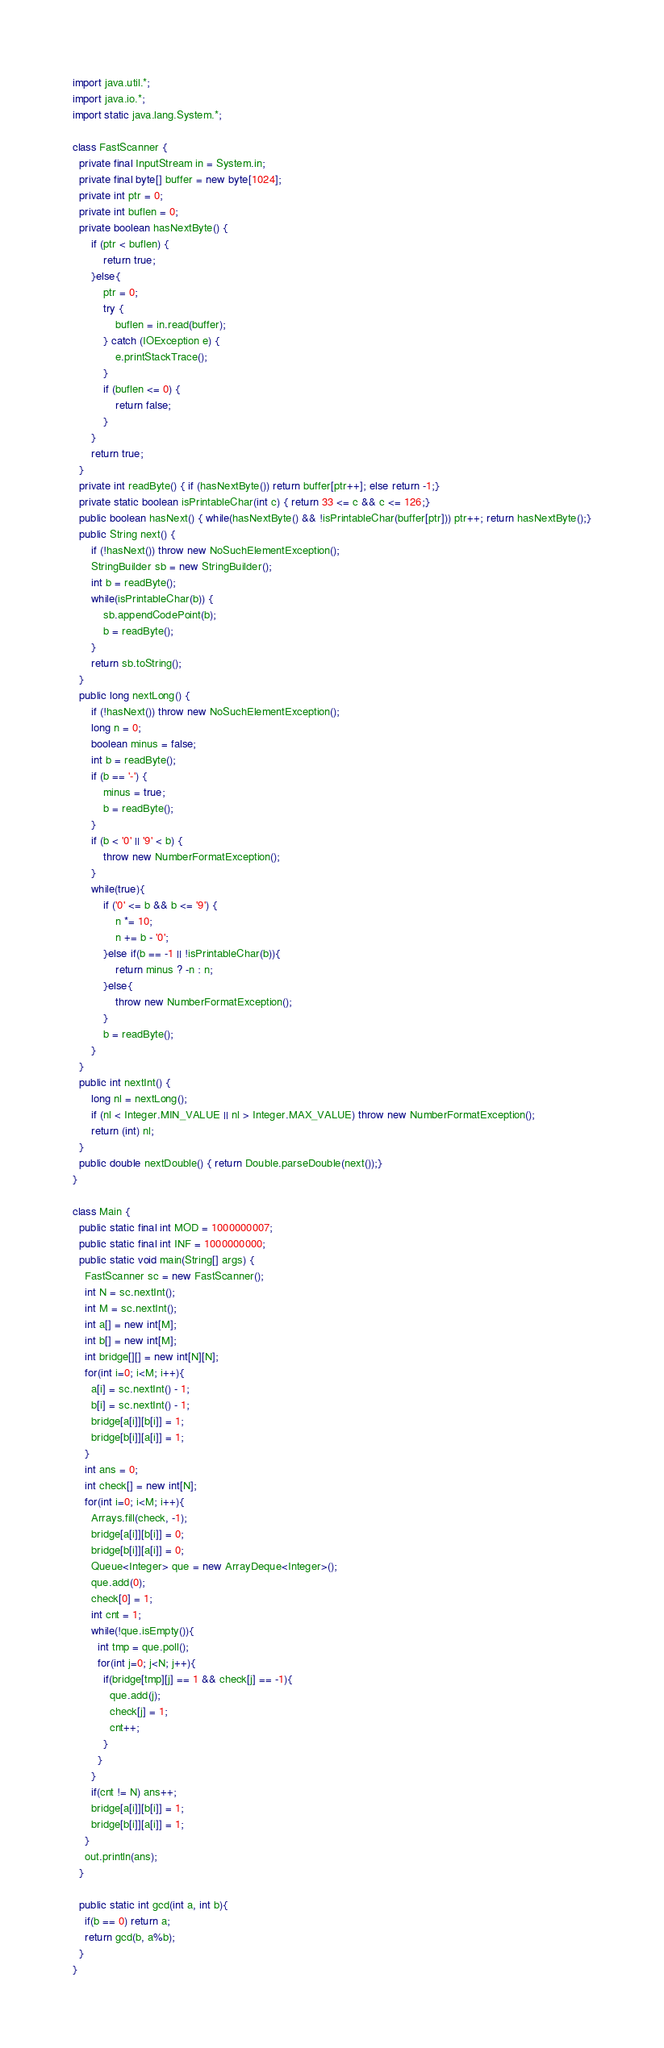Convert code to text. <code><loc_0><loc_0><loc_500><loc_500><_Java_>import java.util.*;
import java.io.*;
import static java.lang.System.*;

class FastScanner {
  private final InputStream in = System.in;
  private final byte[] buffer = new byte[1024];
  private int ptr = 0;
  private int buflen = 0;
  private boolean hasNextByte() {
      if (ptr < buflen) {
          return true;
      }else{
          ptr = 0;
          try {
              buflen = in.read(buffer);
          } catch (IOException e) {
              e.printStackTrace();
          }
          if (buflen <= 0) {
              return false;
          }
      }
      return true;
  }
  private int readByte() { if (hasNextByte()) return buffer[ptr++]; else return -1;}
  private static boolean isPrintableChar(int c) { return 33 <= c && c <= 126;}
  public boolean hasNext() { while(hasNextByte() && !isPrintableChar(buffer[ptr])) ptr++; return hasNextByte();}
  public String next() {
      if (!hasNext()) throw new NoSuchElementException();
      StringBuilder sb = new StringBuilder();
      int b = readByte();
      while(isPrintableChar(b)) {
          sb.appendCodePoint(b);
          b = readByte();
      }
      return sb.toString();
  }
  public long nextLong() {
      if (!hasNext()) throw new NoSuchElementException();
      long n = 0;
      boolean minus = false;
      int b = readByte();
      if (b == '-') {
          minus = true;
          b = readByte();
      }
      if (b < '0' || '9' < b) {
          throw new NumberFormatException();
      }
      while(true){
          if ('0' <= b && b <= '9') {
              n *= 10;
              n += b - '0';
          }else if(b == -1 || !isPrintableChar(b)){
              return minus ? -n : n;
          }else{
              throw new NumberFormatException();
          }
          b = readByte();
      }
  }
  public int nextInt() {
      long nl = nextLong();
      if (nl < Integer.MIN_VALUE || nl > Integer.MAX_VALUE) throw new NumberFormatException();
      return (int) nl;
  }
  public double nextDouble() { return Double.parseDouble(next());}
}

class Main {
  public static final int MOD = 1000000007;
  public static final int INF = 1000000000;
  public static void main(String[] args) {
    FastScanner sc = new FastScanner();
    int N = sc.nextInt();
    int M = sc.nextInt();
    int a[] = new int[M];
    int b[] = new int[M];
    int bridge[][] = new int[N][N];
    for(int i=0; i<M; i++){
      a[i] = sc.nextInt() - 1;
      b[i] = sc.nextInt() - 1;
      bridge[a[i]][b[i]] = 1;
      bridge[b[i]][a[i]] = 1;
    }
    int ans = 0;
    int check[] = new int[N];
    for(int i=0; i<M; i++){
      Arrays.fill(check, -1);
      bridge[a[i]][b[i]] = 0;
      bridge[b[i]][a[i]] = 0;
      Queue<Integer> que = new ArrayDeque<Integer>();
      que.add(0);
      check[0] = 1;
      int cnt = 1;
      while(!que.isEmpty()){
        int tmp = que.poll();
        for(int j=0; j<N; j++){
          if(bridge[tmp][j] == 1 && check[j] == -1){
            que.add(j);
            check[j] = 1;
            cnt++;
          }
        }
      }
      if(cnt != N) ans++;
      bridge[a[i]][b[i]] = 1;
      bridge[b[i]][a[i]] = 1;
    }
    out.println(ans);
  }

  public static int gcd(int a, int b){
    if(b == 0) return a;
    return gcd(b, a%b);
  }
}</code> 